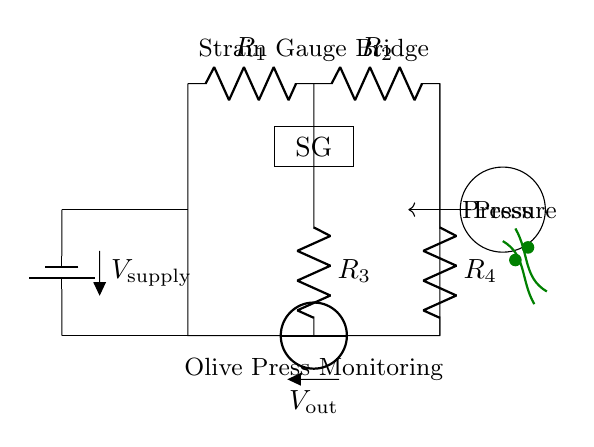What components are present in the circuit? The circuit includes resistors R1, R2, R3, R4, a strain gauge (SG), and a power supply (battery).
Answer: resistors, strain gauge, battery What is the output voltage denoted as in the circuit? The output voltage is labeled as Vout, which is the voltage measured across the strain gauge bridge.
Answer: Vout How many resistors are used in the bridge circuit? There are four resistors in total: R1, R2, R3, and R4.
Answer: four What is the purpose of the strain gauge in this circuit? The strain gauge is used to monitor pressure changes in the olive press by altering its resistance based on applied pressure.
Answer: monitor pressure What is the significance of the battery in the circuit? The battery provides the necessary power supply voltage for the circuit to function and allows for the measurement of changes in output voltage.
Answer: power supply What does the olive press symbol represent in this diagram? The olive press symbol denotes the source of pressure that is being monitored by the strain gauge bridge circuit.
Answer: pressure source Why is this type of circuit referred to as a bridge circuit? It is called a bridge circuit because it consists of two voltage dividers that are connected in a bridge configuration, allowing for the measurement of differential voltage due to the strain gauge.
Answer: bridge configuration 